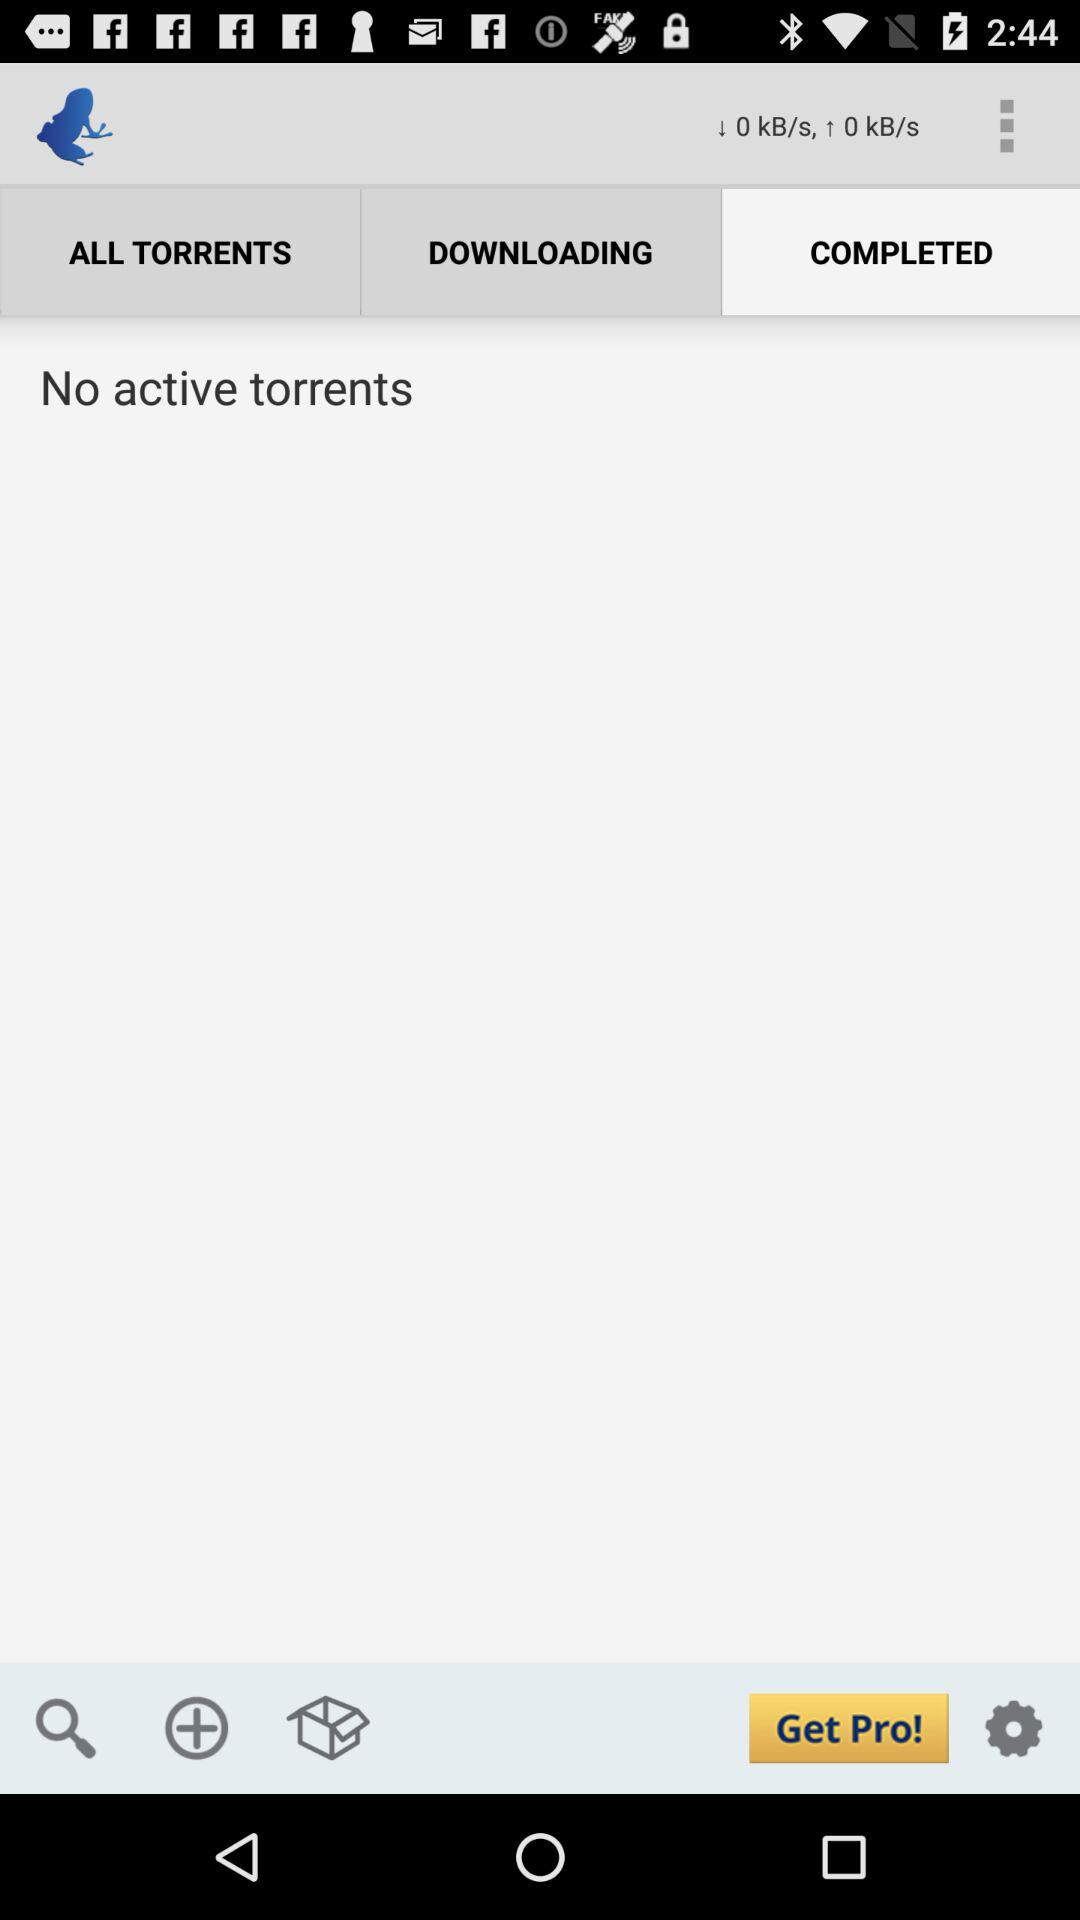Which tab is selected? The selected tab is "COMPLETED". 